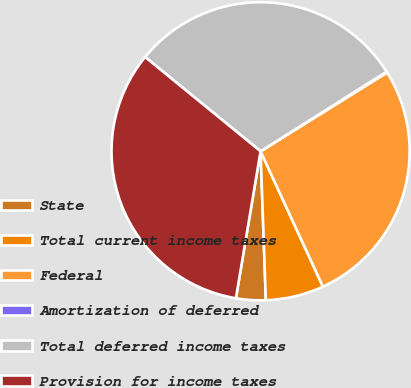Convert chart to OTSL. <chart><loc_0><loc_0><loc_500><loc_500><pie_chart><fcel>State<fcel>Total current income taxes<fcel>Federal<fcel>Amortization of deferred<fcel>Total deferred income taxes<fcel>Provision for income taxes<nl><fcel>3.21%<fcel>6.31%<fcel>26.99%<fcel>0.1%<fcel>30.14%<fcel>33.25%<nl></chart> 